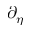Convert formula to latex. <formula><loc_0><loc_0><loc_500><loc_500>\partial _ { \eta }</formula> 